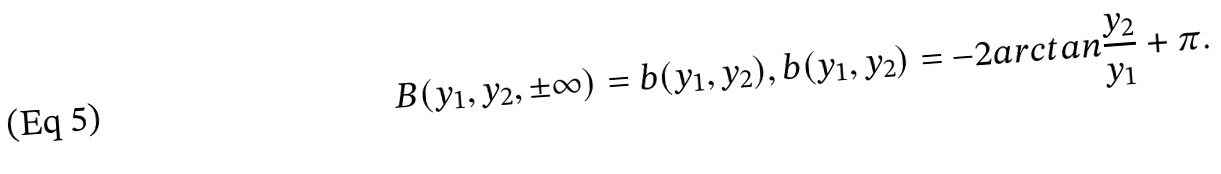Convert formula to latex. <formula><loc_0><loc_0><loc_500><loc_500>B ( y _ { 1 } , y _ { 2 } , \pm \infty ) = b ( y _ { 1 } , y _ { 2 } ) , b ( y _ { 1 } , y _ { 2 } ) = - 2 a r c t a n \frac { y _ { 2 } } { y _ { 1 } } + \pi .</formula> 